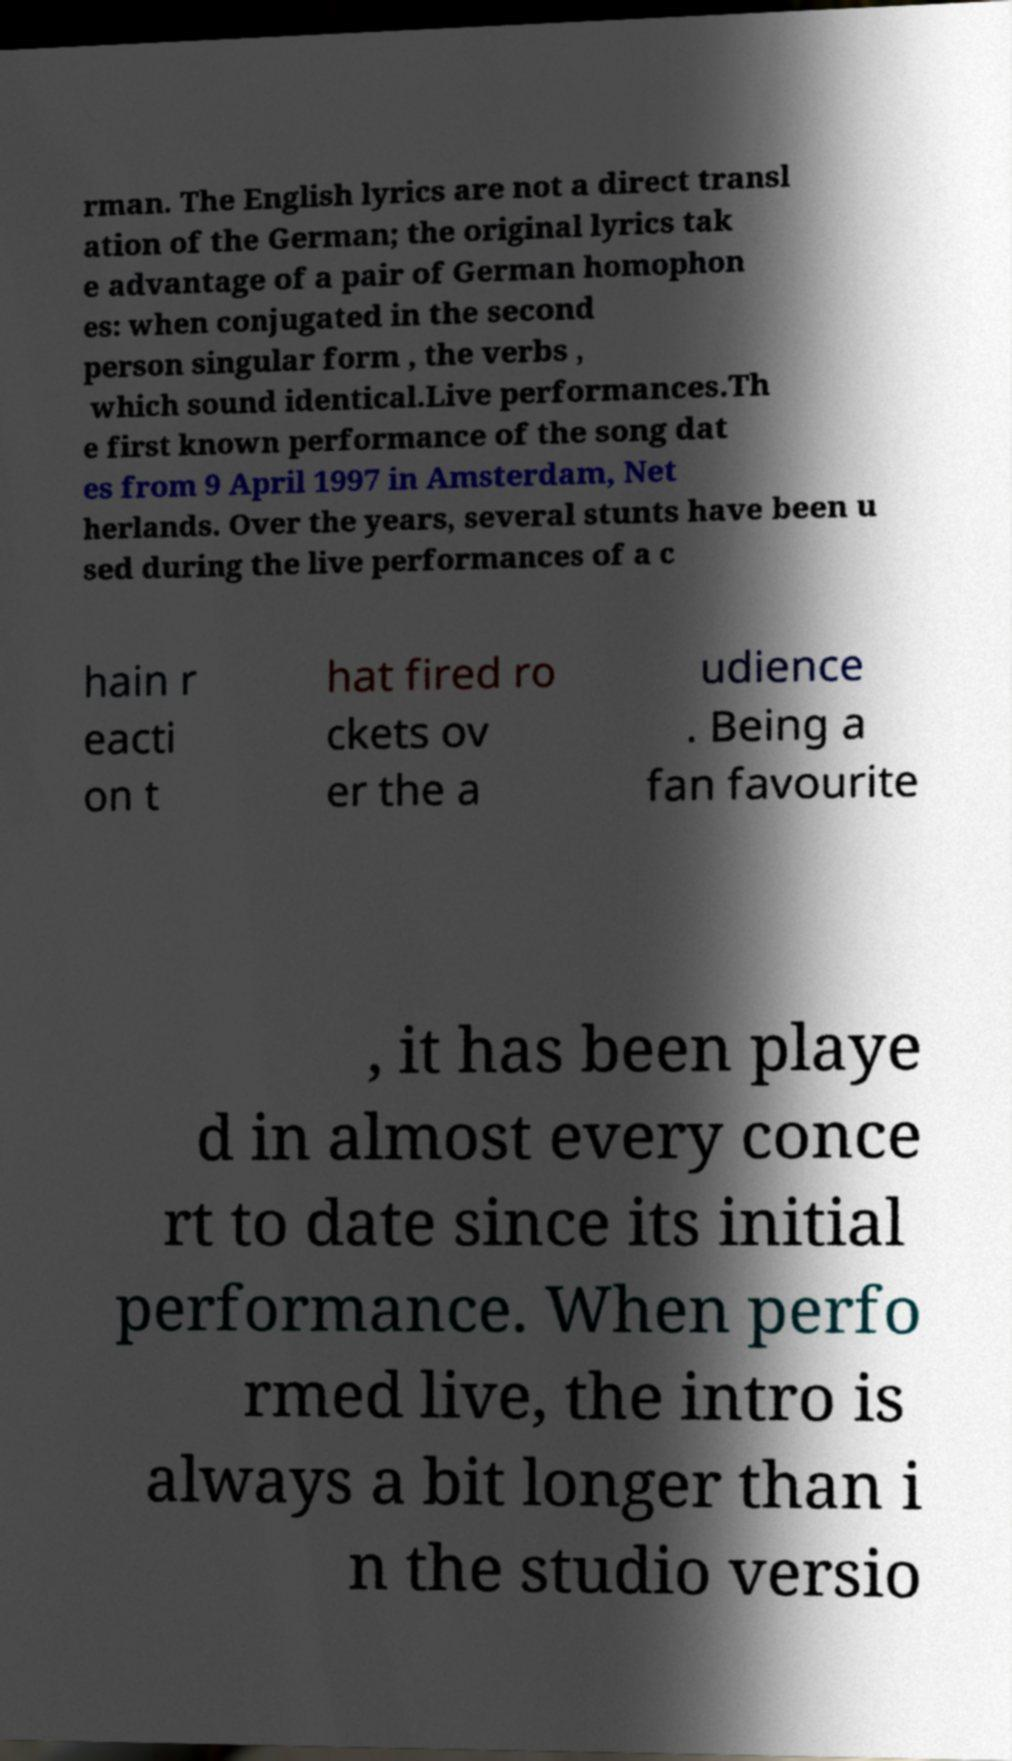Can you read and provide the text displayed in the image?This photo seems to have some interesting text. Can you extract and type it out for me? rman. The English lyrics are not a direct transl ation of the German; the original lyrics tak e advantage of a pair of German homophon es: when conjugated in the second person singular form , the verbs , which sound identical.Live performances.Th e first known performance of the song dat es from 9 April 1997 in Amsterdam, Net herlands. Over the years, several stunts have been u sed during the live performances of a c hain r eacti on t hat fired ro ckets ov er the a udience . Being a fan favourite , it has been playe d in almost every conce rt to date since its initial performance. When perfo rmed live, the intro is always a bit longer than i n the studio versio 